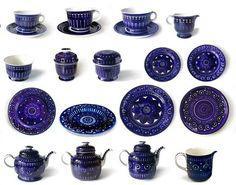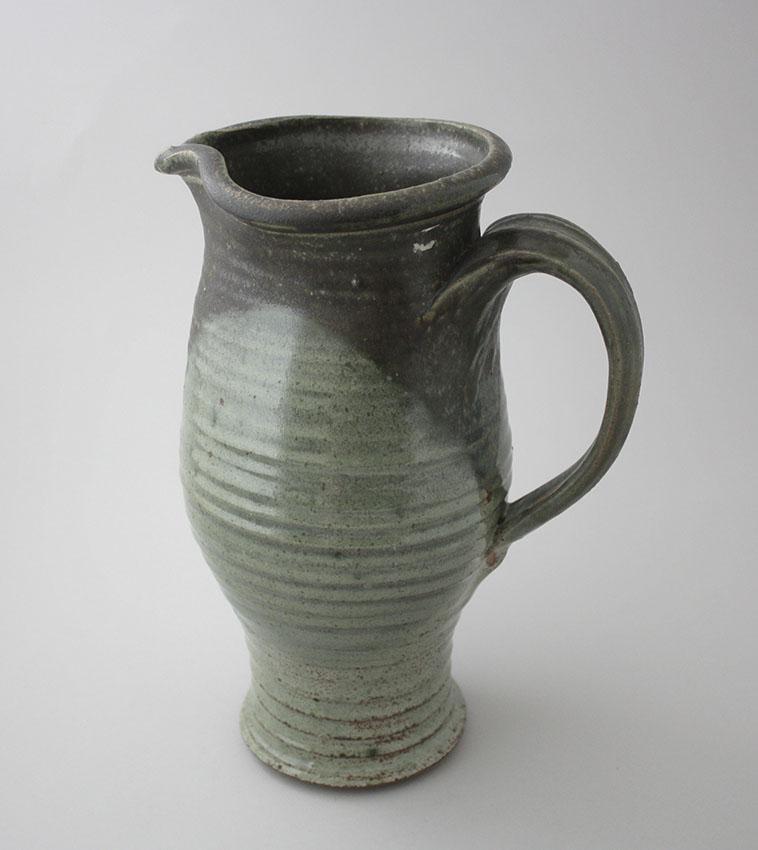The first image is the image on the left, the second image is the image on the right. Examine the images to the left and right. Is the description "The image on the left shows three greenish mugs on a wooden table." accurate? Answer yes or no. No. The first image is the image on the left, the second image is the image on the right. Given the left and right images, does the statement "There are exactly 6 cups, and no other objects." hold true? Answer yes or no. No. 